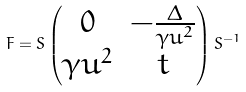<formula> <loc_0><loc_0><loc_500><loc_500>F = S \begin{pmatrix} 0 & - \frac { \Delta } { \gamma u ^ { 2 } } \\ \gamma u ^ { 2 } & t \end{pmatrix} S ^ { - 1 }</formula> 